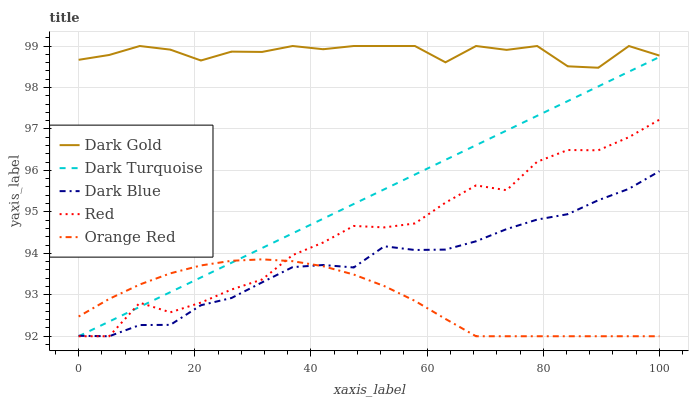Does Orange Red have the minimum area under the curve?
Answer yes or no. Yes. Does Dark Gold have the maximum area under the curve?
Answer yes or no. Yes. Does Dark Blue have the minimum area under the curve?
Answer yes or no. No. Does Dark Blue have the maximum area under the curve?
Answer yes or no. No. Is Dark Turquoise the smoothest?
Answer yes or no. Yes. Is Red the roughest?
Answer yes or no. Yes. Is Orange Red the smoothest?
Answer yes or no. No. Is Orange Red the roughest?
Answer yes or no. No. Does Dark Turquoise have the lowest value?
Answer yes or no. Yes. Does Dark Gold have the lowest value?
Answer yes or no. No. Does Dark Gold have the highest value?
Answer yes or no. Yes. Does Dark Blue have the highest value?
Answer yes or no. No. Is Dark Blue less than Dark Gold?
Answer yes or no. Yes. Is Dark Gold greater than Red?
Answer yes or no. Yes. Does Red intersect Dark Blue?
Answer yes or no. Yes. Is Red less than Dark Blue?
Answer yes or no. No. Is Red greater than Dark Blue?
Answer yes or no. No. Does Dark Blue intersect Dark Gold?
Answer yes or no. No. 